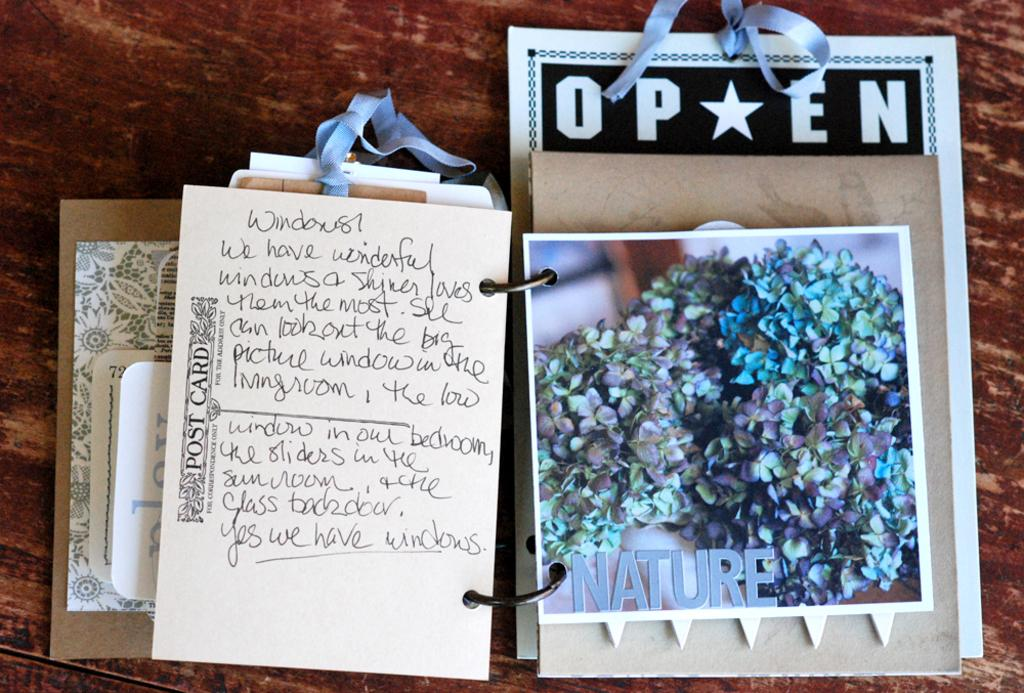What type of surface is visible in the image? There is a wooden surface in the image. What can be found on the wooden surface? There are greetings and text on the wooden surface. Is the wooden surface covered in quicksand in the image? No, there is no quicksand present on the wooden surface in the image. Can you hear the wooden surface talking in the image? The wooden surface cannot talk, as it is an inanimate object. --- Facts: 1. There is a person sitting on a chair in the image. 2. The person is holding a book. 3. There is a table next to the person. 4. There is a lamp on the table. Absurd Topics: elephant, piano, ocean Conversation: What is the main subject in the image? There is a person sitting on a chair in the image. What is the person doing in the image? The person is holding a book in the image. What is located next to the person in the image? There is a table next to the person in the image. What object can be seen on the table in the image? There is a lamp on the table in the image. Reasoning: Let' Let's think step by step in order to produce the conversation. We start by identifying the main subject of the image, which is the person sitting on a chair. Next, we describe the action of the person, which is holding a book. Then, we observe the objects in the image, noting that there is a table next to the person. Finally, we describe the object on the table, which is a lamp. Absurd Question/Answer: Can you see an elephant playing a piano in the ocean in the image? No, there is no elephant playing a piano in the ocean in the image. 